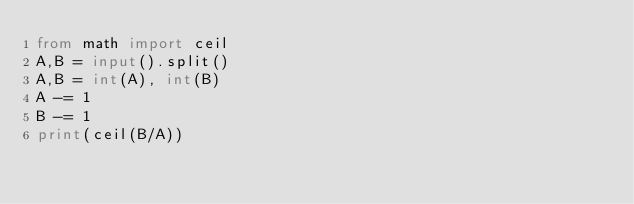Convert code to text. <code><loc_0><loc_0><loc_500><loc_500><_Python_>from math import ceil
A,B = input().split()
A,B = int(A), int(B)
A -= 1
B -= 1
print(ceil(B/A))</code> 